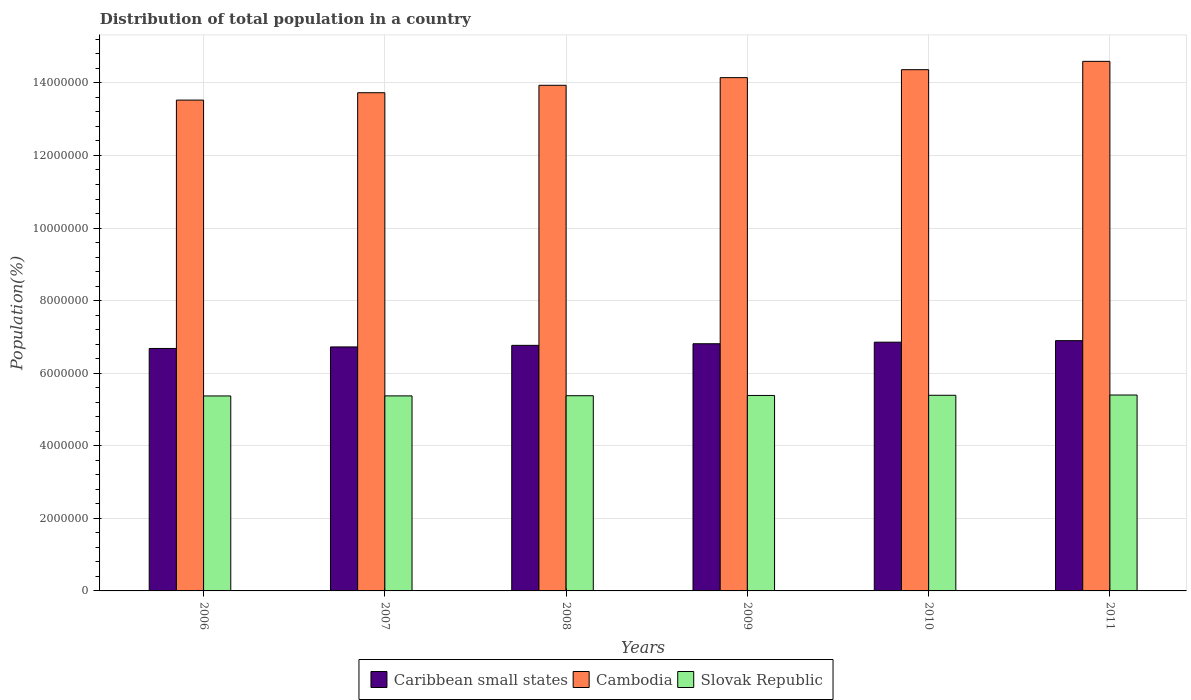How many different coloured bars are there?
Give a very brief answer. 3. Are the number of bars per tick equal to the number of legend labels?
Your response must be concise. Yes. Are the number of bars on each tick of the X-axis equal?
Ensure brevity in your answer.  Yes. What is the label of the 1st group of bars from the left?
Keep it short and to the point. 2006. In how many cases, is the number of bars for a given year not equal to the number of legend labels?
Give a very brief answer. 0. What is the population of in Cambodia in 2011?
Give a very brief answer. 1.46e+07. Across all years, what is the maximum population of in Slovak Republic?
Give a very brief answer. 5.40e+06. Across all years, what is the minimum population of in Caribbean small states?
Keep it short and to the point. 6.68e+06. In which year was the population of in Cambodia maximum?
Offer a very short reply. 2011. What is the total population of in Cambodia in the graph?
Your answer should be compact. 8.43e+07. What is the difference between the population of in Slovak Republic in 2010 and that in 2011?
Your answer should be very brief. -6956. What is the difference between the population of in Slovak Republic in 2007 and the population of in Caribbean small states in 2006?
Offer a terse response. -1.31e+06. What is the average population of in Slovak Republic per year?
Provide a succinct answer. 5.38e+06. In the year 2009, what is the difference between the population of in Caribbean small states and population of in Cambodia?
Your response must be concise. -7.33e+06. In how many years, is the population of in Slovak Republic greater than 6000000 %?
Offer a terse response. 0. What is the ratio of the population of in Cambodia in 2009 to that in 2010?
Your answer should be very brief. 0.98. Is the population of in Slovak Republic in 2007 less than that in 2008?
Your answer should be compact. Yes. What is the difference between the highest and the second highest population of in Slovak Republic?
Provide a short and direct response. 6956. What is the difference between the highest and the lowest population of in Slovak Republic?
Offer a terse response. 2.53e+04. What does the 1st bar from the left in 2008 represents?
Ensure brevity in your answer.  Caribbean small states. What does the 1st bar from the right in 2009 represents?
Your answer should be very brief. Slovak Republic. How many bars are there?
Offer a very short reply. 18. Are all the bars in the graph horizontal?
Your answer should be compact. No. How many years are there in the graph?
Provide a succinct answer. 6. What is the difference between two consecutive major ticks on the Y-axis?
Ensure brevity in your answer.  2.00e+06. Are the values on the major ticks of Y-axis written in scientific E-notation?
Give a very brief answer. No. How are the legend labels stacked?
Ensure brevity in your answer.  Horizontal. What is the title of the graph?
Offer a terse response. Distribution of total population in a country. What is the label or title of the Y-axis?
Give a very brief answer. Population(%). What is the Population(%) of Caribbean small states in 2006?
Provide a short and direct response. 6.68e+06. What is the Population(%) in Cambodia in 2006?
Offer a very short reply. 1.35e+07. What is the Population(%) of Slovak Republic in 2006?
Offer a very short reply. 5.37e+06. What is the Population(%) of Caribbean small states in 2007?
Provide a short and direct response. 6.72e+06. What is the Population(%) of Cambodia in 2007?
Your answer should be very brief. 1.37e+07. What is the Population(%) of Slovak Republic in 2007?
Ensure brevity in your answer.  5.37e+06. What is the Population(%) in Caribbean small states in 2008?
Give a very brief answer. 6.77e+06. What is the Population(%) in Cambodia in 2008?
Make the answer very short. 1.39e+07. What is the Population(%) in Slovak Republic in 2008?
Keep it short and to the point. 5.38e+06. What is the Population(%) in Caribbean small states in 2009?
Ensure brevity in your answer.  6.81e+06. What is the Population(%) of Cambodia in 2009?
Offer a terse response. 1.41e+07. What is the Population(%) in Slovak Republic in 2009?
Provide a short and direct response. 5.39e+06. What is the Population(%) in Caribbean small states in 2010?
Your answer should be very brief. 6.85e+06. What is the Population(%) of Cambodia in 2010?
Ensure brevity in your answer.  1.44e+07. What is the Population(%) of Slovak Republic in 2010?
Give a very brief answer. 5.39e+06. What is the Population(%) of Caribbean small states in 2011?
Your answer should be compact. 6.90e+06. What is the Population(%) of Cambodia in 2011?
Your answer should be very brief. 1.46e+07. What is the Population(%) of Slovak Republic in 2011?
Your response must be concise. 5.40e+06. Across all years, what is the maximum Population(%) in Caribbean small states?
Your answer should be compact. 6.90e+06. Across all years, what is the maximum Population(%) in Cambodia?
Give a very brief answer. 1.46e+07. Across all years, what is the maximum Population(%) in Slovak Republic?
Ensure brevity in your answer.  5.40e+06. Across all years, what is the minimum Population(%) in Caribbean small states?
Offer a terse response. 6.68e+06. Across all years, what is the minimum Population(%) of Cambodia?
Ensure brevity in your answer.  1.35e+07. Across all years, what is the minimum Population(%) in Slovak Republic?
Provide a short and direct response. 5.37e+06. What is the total Population(%) of Caribbean small states in the graph?
Offer a very short reply. 4.07e+07. What is the total Population(%) in Cambodia in the graph?
Your answer should be compact. 8.43e+07. What is the total Population(%) in Slovak Republic in the graph?
Your response must be concise. 3.23e+07. What is the difference between the Population(%) of Caribbean small states in 2006 and that in 2007?
Your answer should be compact. -4.24e+04. What is the difference between the Population(%) in Cambodia in 2006 and that in 2007?
Your response must be concise. -2.03e+05. What is the difference between the Population(%) of Slovak Republic in 2006 and that in 2007?
Give a very brief answer. -1568. What is the difference between the Population(%) of Caribbean small states in 2006 and that in 2008?
Provide a succinct answer. -8.60e+04. What is the difference between the Population(%) in Cambodia in 2006 and that in 2008?
Give a very brief answer. -4.08e+05. What is the difference between the Population(%) in Slovak Republic in 2006 and that in 2008?
Offer a very short reply. -6179. What is the difference between the Population(%) in Caribbean small states in 2006 and that in 2009?
Provide a short and direct response. -1.30e+05. What is the difference between the Population(%) of Cambodia in 2006 and that in 2009?
Offer a terse response. -6.19e+05. What is the difference between the Population(%) of Slovak Republic in 2006 and that in 2009?
Provide a short and direct response. -1.34e+04. What is the difference between the Population(%) of Caribbean small states in 2006 and that in 2010?
Keep it short and to the point. -1.73e+05. What is the difference between the Population(%) of Cambodia in 2006 and that in 2010?
Ensure brevity in your answer.  -8.38e+05. What is the difference between the Population(%) in Slovak Republic in 2006 and that in 2010?
Offer a terse response. -1.84e+04. What is the difference between the Population(%) in Caribbean small states in 2006 and that in 2011?
Your answer should be very brief. -2.15e+05. What is the difference between the Population(%) in Cambodia in 2006 and that in 2011?
Provide a succinct answer. -1.07e+06. What is the difference between the Population(%) in Slovak Republic in 2006 and that in 2011?
Provide a succinct answer. -2.53e+04. What is the difference between the Population(%) in Caribbean small states in 2007 and that in 2008?
Make the answer very short. -4.37e+04. What is the difference between the Population(%) of Cambodia in 2007 and that in 2008?
Ensure brevity in your answer.  -2.05e+05. What is the difference between the Population(%) of Slovak Republic in 2007 and that in 2008?
Provide a succinct answer. -4611. What is the difference between the Population(%) in Caribbean small states in 2007 and that in 2009?
Your answer should be very brief. -8.76e+04. What is the difference between the Population(%) of Cambodia in 2007 and that in 2009?
Offer a terse response. -4.16e+05. What is the difference between the Population(%) of Slovak Republic in 2007 and that in 2009?
Provide a succinct answer. -1.18e+04. What is the difference between the Population(%) in Caribbean small states in 2007 and that in 2010?
Offer a terse response. -1.31e+05. What is the difference between the Population(%) of Cambodia in 2007 and that in 2010?
Offer a terse response. -6.35e+05. What is the difference between the Population(%) of Slovak Republic in 2007 and that in 2010?
Give a very brief answer. -1.68e+04. What is the difference between the Population(%) in Caribbean small states in 2007 and that in 2011?
Your response must be concise. -1.73e+05. What is the difference between the Population(%) of Cambodia in 2007 and that in 2011?
Your answer should be compact. -8.64e+05. What is the difference between the Population(%) of Slovak Republic in 2007 and that in 2011?
Your response must be concise. -2.38e+04. What is the difference between the Population(%) of Caribbean small states in 2008 and that in 2009?
Make the answer very short. -4.39e+04. What is the difference between the Population(%) of Cambodia in 2008 and that in 2009?
Ensure brevity in your answer.  -2.11e+05. What is the difference between the Population(%) of Slovak Republic in 2008 and that in 2009?
Offer a very short reply. -7173. What is the difference between the Population(%) of Caribbean small states in 2008 and that in 2010?
Offer a terse response. -8.73e+04. What is the difference between the Population(%) in Cambodia in 2008 and that in 2010?
Offer a terse response. -4.30e+05. What is the difference between the Population(%) of Slovak Republic in 2008 and that in 2010?
Offer a very short reply. -1.22e+04. What is the difference between the Population(%) of Caribbean small states in 2008 and that in 2011?
Give a very brief answer. -1.29e+05. What is the difference between the Population(%) of Cambodia in 2008 and that in 2011?
Give a very brief answer. -6.59e+05. What is the difference between the Population(%) in Slovak Republic in 2008 and that in 2011?
Your answer should be very brief. -1.92e+04. What is the difference between the Population(%) in Caribbean small states in 2009 and that in 2010?
Your response must be concise. -4.34e+04. What is the difference between the Population(%) in Cambodia in 2009 and that in 2010?
Ensure brevity in your answer.  -2.19e+05. What is the difference between the Population(%) in Slovak Republic in 2009 and that in 2010?
Offer a very short reply. -5022. What is the difference between the Population(%) in Caribbean small states in 2009 and that in 2011?
Provide a short and direct response. -8.55e+04. What is the difference between the Population(%) in Cambodia in 2009 and that in 2011?
Make the answer very short. -4.49e+05. What is the difference between the Population(%) in Slovak Republic in 2009 and that in 2011?
Provide a short and direct response. -1.20e+04. What is the difference between the Population(%) in Caribbean small states in 2010 and that in 2011?
Offer a very short reply. -4.21e+04. What is the difference between the Population(%) in Cambodia in 2010 and that in 2011?
Your answer should be compact. -2.30e+05. What is the difference between the Population(%) in Slovak Republic in 2010 and that in 2011?
Ensure brevity in your answer.  -6956. What is the difference between the Population(%) of Caribbean small states in 2006 and the Population(%) of Cambodia in 2007?
Make the answer very short. -7.05e+06. What is the difference between the Population(%) of Caribbean small states in 2006 and the Population(%) of Slovak Republic in 2007?
Give a very brief answer. 1.31e+06. What is the difference between the Population(%) in Cambodia in 2006 and the Population(%) in Slovak Republic in 2007?
Your response must be concise. 8.15e+06. What is the difference between the Population(%) in Caribbean small states in 2006 and the Population(%) in Cambodia in 2008?
Ensure brevity in your answer.  -7.25e+06. What is the difference between the Population(%) in Caribbean small states in 2006 and the Population(%) in Slovak Republic in 2008?
Keep it short and to the point. 1.30e+06. What is the difference between the Population(%) of Cambodia in 2006 and the Population(%) of Slovak Republic in 2008?
Ensure brevity in your answer.  8.15e+06. What is the difference between the Population(%) of Caribbean small states in 2006 and the Population(%) of Cambodia in 2009?
Make the answer very short. -7.46e+06. What is the difference between the Population(%) in Caribbean small states in 2006 and the Population(%) in Slovak Republic in 2009?
Offer a very short reply. 1.29e+06. What is the difference between the Population(%) in Cambodia in 2006 and the Population(%) in Slovak Republic in 2009?
Give a very brief answer. 8.14e+06. What is the difference between the Population(%) in Caribbean small states in 2006 and the Population(%) in Cambodia in 2010?
Your response must be concise. -7.68e+06. What is the difference between the Population(%) in Caribbean small states in 2006 and the Population(%) in Slovak Republic in 2010?
Your answer should be compact. 1.29e+06. What is the difference between the Population(%) in Cambodia in 2006 and the Population(%) in Slovak Republic in 2010?
Keep it short and to the point. 8.13e+06. What is the difference between the Population(%) of Caribbean small states in 2006 and the Population(%) of Cambodia in 2011?
Keep it short and to the point. -7.91e+06. What is the difference between the Population(%) of Caribbean small states in 2006 and the Population(%) of Slovak Republic in 2011?
Your answer should be compact. 1.28e+06. What is the difference between the Population(%) of Cambodia in 2006 and the Population(%) of Slovak Republic in 2011?
Your response must be concise. 8.13e+06. What is the difference between the Population(%) of Caribbean small states in 2007 and the Population(%) of Cambodia in 2008?
Keep it short and to the point. -7.21e+06. What is the difference between the Population(%) of Caribbean small states in 2007 and the Population(%) of Slovak Republic in 2008?
Keep it short and to the point. 1.34e+06. What is the difference between the Population(%) in Cambodia in 2007 and the Population(%) in Slovak Republic in 2008?
Your answer should be very brief. 8.35e+06. What is the difference between the Population(%) in Caribbean small states in 2007 and the Population(%) in Cambodia in 2009?
Offer a terse response. -7.42e+06. What is the difference between the Population(%) in Caribbean small states in 2007 and the Population(%) in Slovak Republic in 2009?
Your response must be concise. 1.34e+06. What is the difference between the Population(%) of Cambodia in 2007 and the Population(%) of Slovak Republic in 2009?
Your response must be concise. 8.34e+06. What is the difference between the Population(%) in Caribbean small states in 2007 and the Population(%) in Cambodia in 2010?
Provide a succinct answer. -7.64e+06. What is the difference between the Population(%) of Caribbean small states in 2007 and the Population(%) of Slovak Republic in 2010?
Ensure brevity in your answer.  1.33e+06. What is the difference between the Population(%) in Cambodia in 2007 and the Population(%) in Slovak Republic in 2010?
Your answer should be very brief. 8.34e+06. What is the difference between the Population(%) of Caribbean small states in 2007 and the Population(%) of Cambodia in 2011?
Offer a terse response. -7.87e+06. What is the difference between the Population(%) of Caribbean small states in 2007 and the Population(%) of Slovak Republic in 2011?
Your response must be concise. 1.33e+06. What is the difference between the Population(%) of Cambodia in 2007 and the Population(%) of Slovak Republic in 2011?
Ensure brevity in your answer.  8.33e+06. What is the difference between the Population(%) in Caribbean small states in 2008 and the Population(%) in Cambodia in 2009?
Offer a very short reply. -7.38e+06. What is the difference between the Population(%) of Caribbean small states in 2008 and the Population(%) of Slovak Republic in 2009?
Keep it short and to the point. 1.38e+06. What is the difference between the Population(%) in Cambodia in 2008 and the Population(%) in Slovak Republic in 2009?
Ensure brevity in your answer.  8.55e+06. What is the difference between the Population(%) of Caribbean small states in 2008 and the Population(%) of Cambodia in 2010?
Offer a terse response. -7.60e+06. What is the difference between the Population(%) of Caribbean small states in 2008 and the Population(%) of Slovak Republic in 2010?
Offer a very short reply. 1.38e+06. What is the difference between the Population(%) in Cambodia in 2008 and the Population(%) in Slovak Republic in 2010?
Your answer should be compact. 8.54e+06. What is the difference between the Population(%) in Caribbean small states in 2008 and the Population(%) in Cambodia in 2011?
Offer a very short reply. -7.83e+06. What is the difference between the Population(%) in Caribbean small states in 2008 and the Population(%) in Slovak Republic in 2011?
Offer a very short reply. 1.37e+06. What is the difference between the Population(%) of Cambodia in 2008 and the Population(%) of Slovak Republic in 2011?
Provide a succinct answer. 8.54e+06. What is the difference between the Population(%) of Caribbean small states in 2009 and the Population(%) of Cambodia in 2010?
Offer a very short reply. -7.55e+06. What is the difference between the Population(%) in Caribbean small states in 2009 and the Population(%) in Slovak Republic in 2010?
Provide a succinct answer. 1.42e+06. What is the difference between the Population(%) of Cambodia in 2009 and the Population(%) of Slovak Republic in 2010?
Make the answer very short. 8.75e+06. What is the difference between the Population(%) of Caribbean small states in 2009 and the Population(%) of Cambodia in 2011?
Provide a succinct answer. -7.78e+06. What is the difference between the Population(%) of Caribbean small states in 2009 and the Population(%) of Slovak Republic in 2011?
Give a very brief answer. 1.41e+06. What is the difference between the Population(%) of Cambodia in 2009 and the Population(%) of Slovak Republic in 2011?
Your answer should be compact. 8.75e+06. What is the difference between the Population(%) of Caribbean small states in 2010 and the Population(%) of Cambodia in 2011?
Offer a terse response. -7.74e+06. What is the difference between the Population(%) of Caribbean small states in 2010 and the Population(%) of Slovak Republic in 2011?
Give a very brief answer. 1.46e+06. What is the difference between the Population(%) in Cambodia in 2010 and the Population(%) in Slovak Republic in 2011?
Make the answer very short. 8.97e+06. What is the average Population(%) in Caribbean small states per year?
Make the answer very short. 6.79e+06. What is the average Population(%) in Cambodia per year?
Make the answer very short. 1.40e+07. What is the average Population(%) in Slovak Republic per year?
Provide a short and direct response. 5.38e+06. In the year 2006, what is the difference between the Population(%) of Caribbean small states and Population(%) of Cambodia?
Ensure brevity in your answer.  -6.84e+06. In the year 2006, what is the difference between the Population(%) in Caribbean small states and Population(%) in Slovak Republic?
Your answer should be compact. 1.31e+06. In the year 2006, what is the difference between the Population(%) in Cambodia and Population(%) in Slovak Republic?
Give a very brief answer. 8.15e+06. In the year 2007, what is the difference between the Population(%) in Caribbean small states and Population(%) in Cambodia?
Keep it short and to the point. -7.01e+06. In the year 2007, what is the difference between the Population(%) of Caribbean small states and Population(%) of Slovak Republic?
Ensure brevity in your answer.  1.35e+06. In the year 2007, what is the difference between the Population(%) in Cambodia and Population(%) in Slovak Republic?
Ensure brevity in your answer.  8.35e+06. In the year 2008, what is the difference between the Population(%) of Caribbean small states and Population(%) of Cambodia?
Provide a short and direct response. -7.17e+06. In the year 2008, what is the difference between the Population(%) in Caribbean small states and Population(%) in Slovak Republic?
Your response must be concise. 1.39e+06. In the year 2008, what is the difference between the Population(%) in Cambodia and Population(%) in Slovak Republic?
Your answer should be compact. 8.55e+06. In the year 2009, what is the difference between the Population(%) of Caribbean small states and Population(%) of Cambodia?
Ensure brevity in your answer.  -7.33e+06. In the year 2009, what is the difference between the Population(%) of Caribbean small states and Population(%) of Slovak Republic?
Offer a very short reply. 1.42e+06. In the year 2009, what is the difference between the Population(%) of Cambodia and Population(%) of Slovak Republic?
Your response must be concise. 8.76e+06. In the year 2010, what is the difference between the Population(%) of Caribbean small states and Population(%) of Cambodia?
Ensure brevity in your answer.  -7.51e+06. In the year 2010, what is the difference between the Population(%) in Caribbean small states and Population(%) in Slovak Republic?
Make the answer very short. 1.46e+06. In the year 2010, what is the difference between the Population(%) of Cambodia and Population(%) of Slovak Republic?
Offer a very short reply. 8.97e+06. In the year 2011, what is the difference between the Population(%) of Caribbean small states and Population(%) of Cambodia?
Your response must be concise. -7.70e+06. In the year 2011, what is the difference between the Population(%) in Caribbean small states and Population(%) in Slovak Republic?
Keep it short and to the point. 1.50e+06. In the year 2011, what is the difference between the Population(%) of Cambodia and Population(%) of Slovak Republic?
Keep it short and to the point. 9.19e+06. What is the ratio of the Population(%) of Caribbean small states in 2006 to that in 2007?
Ensure brevity in your answer.  0.99. What is the ratio of the Population(%) of Cambodia in 2006 to that in 2007?
Give a very brief answer. 0.99. What is the ratio of the Population(%) in Caribbean small states in 2006 to that in 2008?
Your response must be concise. 0.99. What is the ratio of the Population(%) in Cambodia in 2006 to that in 2008?
Your response must be concise. 0.97. What is the ratio of the Population(%) in Caribbean small states in 2006 to that in 2009?
Keep it short and to the point. 0.98. What is the ratio of the Population(%) of Cambodia in 2006 to that in 2009?
Provide a short and direct response. 0.96. What is the ratio of the Population(%) in Caribbean small states in 2006 to that in 2010?
Give a very brief answer. 0.97. What is the ratio of the Population(%) of Cambodia in 2006 to that in 2010?
Make the answer very short. 0.94. What is the ratio of the Population(%) of Caribbean small states in 2006 to that in 2011?
Make the answer very short. 0.97. What is the ratio of the Population(%) in Cambodia in 2006 to that in 2011?
Ensure brevity in your answer.  0.93. What is the ratio of the Population(%) in Slovak Republic in 2006 to that in 2011?
Provide a short and direct response. 1. What is the ratio of the Population(%) of Caribbean small states in 2007 to that in 2009?
Give a very brief answer. 0.99. What is the ratio of the Population(%) of Cambodia in 2007 to that in 2009?
Offer a very short reply. 0.97. What is the ratio of the Population(%) in Caribbean small states in 2007 to that in 2010?
Offer a terse response. 0.98. What is the ratio of the Population(%) of Cambodia in 2007 to that in 2010?
Keep it short and to the point. 0.96. What is the ratio of the Population(%) of Slovak Republic in 2007 to that in 2010?
Provide a short and direct response. 1. What is the ratio of the Population(%) in Caribbean small states in 2007 to that in 2011?
Give a very brief answer. 0.97. What is the ratio of the Population(%) in Cambodia in 2007 to that in 2011?
Your answer should be very brief. 0.94. What is the ratio of the Population(%) of Slovak Republic in 2007 to that in 2011?
Offer a very short reply. 1. What is the ratio of the Population(%) of Cambodia in 2008 to that in 2009?
Keep it short and to the point. 0.99. What is the ratio of the Population(%) in Slovak Republic in 2008 to that in 2009?
Your response must be concise. 1. What is the ratio of the Population(%) of Caribbean small states in 2008 to that in 2010?
Your answer should be compact. 0.99. What is the ratio of the Population(%) of Cambodia in 2008 to that in 2010?
Offer a terse response. 0.97. What is the ratio of the Population(%) of Slovak Republic in 2008 to that in 2010?
Provide a succinct answer. 1. What is the ratio of the Population(%) of Caribbean small states in 2008 to that in 2011?
Offer a terse response. 0.98. What is the ratio of the Population(%) of Cambodia in 2008 to that in 2011?
Provide a succinct answer. 0.95. What is the ratio of the Population(%) in Slovak Republic in 2008 to that in 2011?
Provide a succinct answer. 1. What is the ratio of the Population(%) in Cambodia in 2009 to that in 2010?
Provide a short and direct response. 0.98. What is the ratio of the Population(%) of Slovak Republic in 2009 to that in 2010?
Your response must be concise. 1. What is the ratio of the Population(%) of Caribbean small states in 2009 to that in 2011?
Ensure brevity in your answer.  0.99. What is the ratio of the Population(%) in Cambodia in 2009 to that in 2011?
Your response must be concise. 0.97. What is the ratio of the Population(%) in Slovak Republic in 2009 to that in 2011?
Your answer should be compact. 1. What is the ratio of the Population(%) in Cambodia in 2010 to that in 2011?
Ensure brevity in your answer.  0.98. What is the ratio of the Population(%) of Slovak Republic in 2010 to that in 2011?
Your response must be concise. 1. What is the difference between the highest and the second highest Population(%) of Caribbean small states?
Offer a very short reply. 4.21e+04. What is the difference between the highest and the second highest Population(%) of Cambodia?
Provide a succinct answer. 2.30e+05. What is the difference between the highest and the second highest Population(%) of Slovak Republic?
Offer a terse response. 6956. What is the difference between the highest and the lowest Population(%) in Caribbean small states?
Keep it short and to the point. 2.15e+05. What is the difference between the highest and the lowest Population(%) in Cambodia?
Make the answer very short. 1.07e+06. What is the difference between the highest and the lowest Population(%) of Slovak Republic?
Your answer should be very brief. 2.53e+04. 